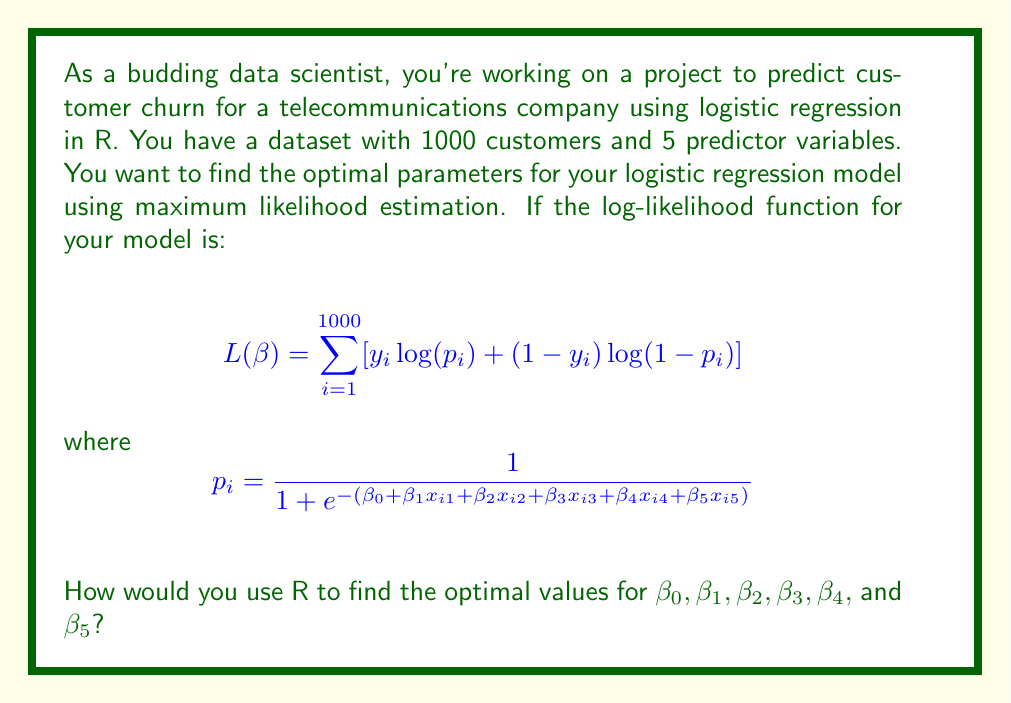Help me with this question. To find the optimal parameters for a logistic regression model in R, you would typically use the following steps:

1. Load the necessary libraries:
   ```R
   library(stats)
   ```

2. Assuming your data is in a dataframe called 'churn_data' with the response variable 'y' and predictor variables 'x1' through 'x5', you would fit the logistic regression model using the `glm()` function:

   ```R
   model <- glm(y ~ x1 + x2 + x3 + x4 + x5, data = churn_data, family = binomial(link = "logit"))
   ```

   The `glm()` function uses iteratively reweighted least squares (IRLS) to perform maximum likelihood estimation and find the optimal parameters.

3. To view the estimated coefficients (optimal parameters):
   ```R
   summary(model)
   ```

   This will display the estimated $\beta$ values along with their standard errors, z-values, and p-values.

4. To extract just the coefficient values:
   ```R
   coef(model)
   ```

The `glm()` function in R internally maximizes the log-likelihood function you provided:

$$L(\beta) = \sum_{i=1}^{1000} [y_i \log(p_i) + (1-y_i) \log(1-p_i)]$$

where $p_i$ is the probability of the positive class (churn in this case) for the i-th observation, given by the logistic function:

$$p_i = \frac{1}{1 + e^{-(\beta_0 + \beta_1x_{i1} + \beta_2x_{i2} + \beta_3x_{i3} + \beta_4x_{i4} + \beta_5x_{i5})}}$$

The optimization process finds the values of $\beta_0, \beta_1, \beta_2, \beta_3, \beta_4,$ and $\beta_5$ that maximize this log-likelihood function.

It's worth noting that R's `glm()` function uses efficient numerical optimization methods to find these parameters, so you don't need to implement the optimization algorithm yourself.
Answer: To find the optimal parameters for the logistic regression model in R, use:

```R
model <- glm(y ~ x1 + x2 + x3 + x4 + x5, data = churn_data, family = binomial(link = "logit"))
coef(model)
```

This will return the optimal values for $\beta_0, \beta_1, \beta_2, \beta_3, \beta_4,$ and $\beta_5$. 